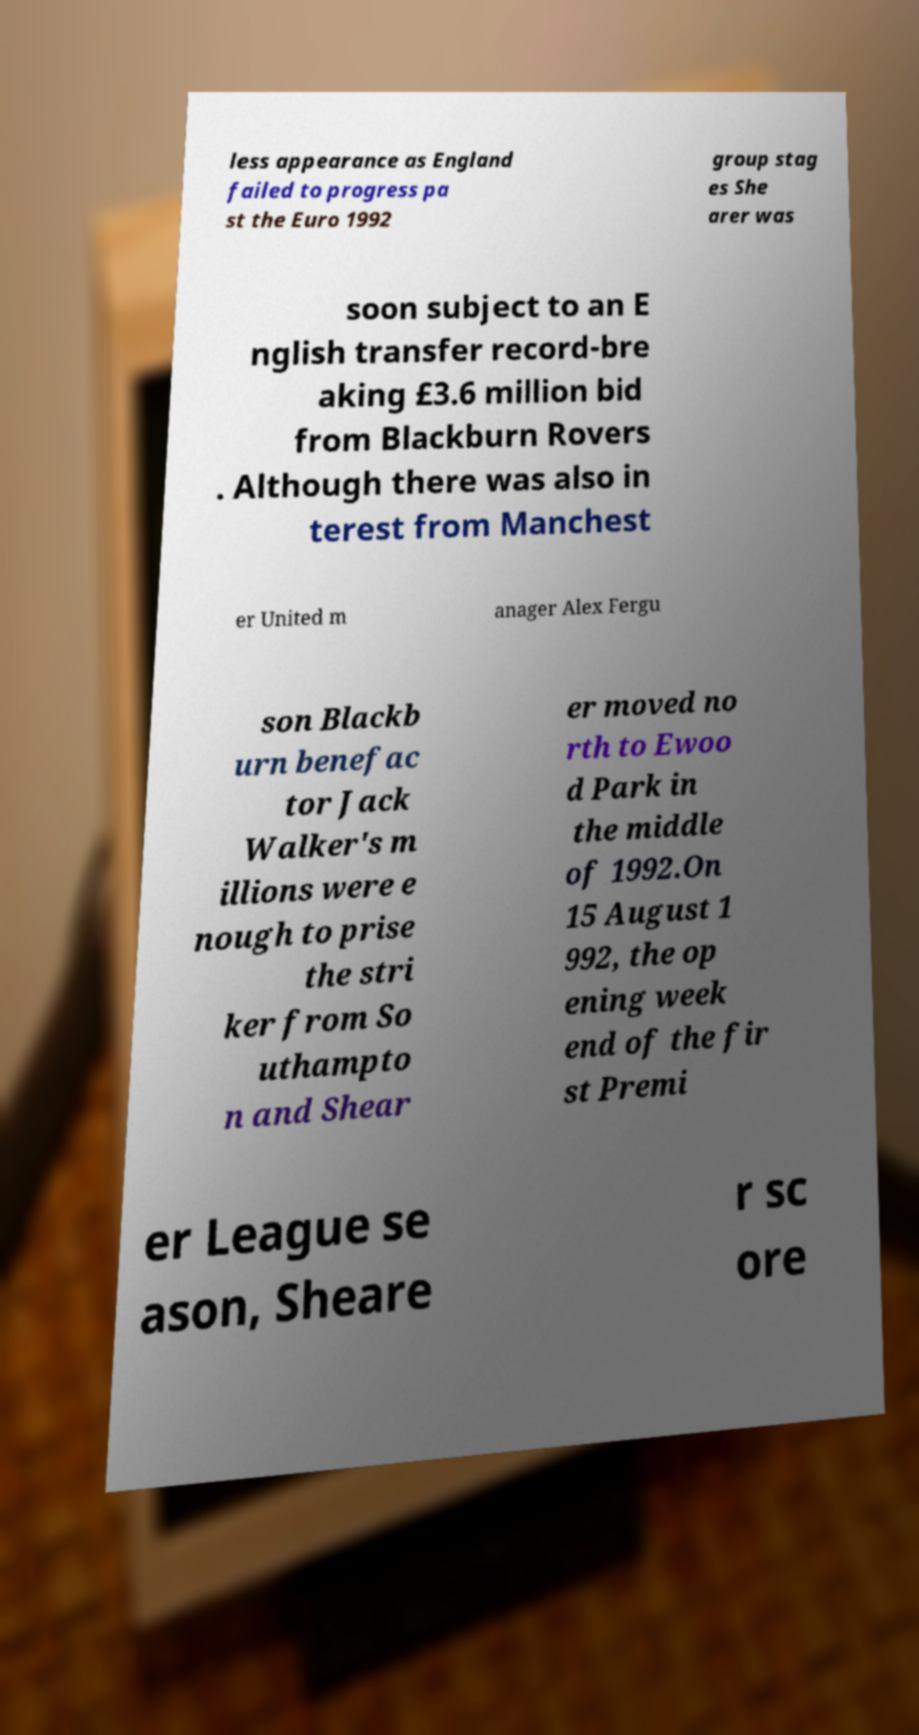Can you accurately transcribe the text from the provided image for me? less appearance as England failed to progress pa st the Euro 1992 group stag es She arer was soon subject to an E nglish transfer record-bre aking £3.6 million bid from Blackburn Rovers . Although there was also in terest from Manchest er United m anager Alex Fergu son Blackb urn benefac tor Jack Walker's m illions were e nough to prise the stri ker from So uthampto n and Shear er moved no rth to Ewoo d Park in the middle of 1992.On 15 August 1 992, the op ening week end of the fir st Premi er League se ason, Sheare r sc ore 